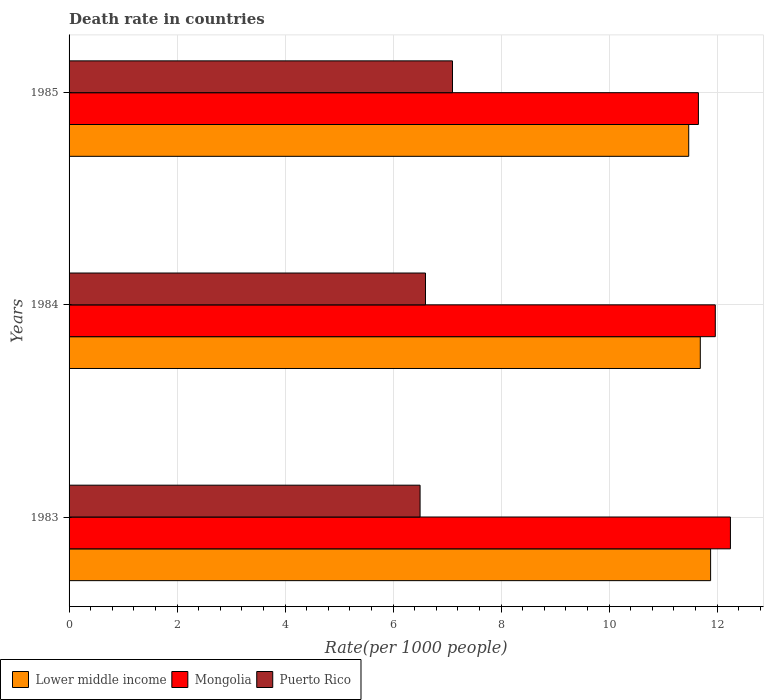Are the number of bars per tick equal to the number of legend labels?
Give a very brief answer. Yes. Are the number of bars on each tick of the Y-axis equal?
Keep it short and to the point. Yes. What is the label of the 2nd group of bars from the top?
Make the answer very short. 1984. In how many cases, is the number of bars for a given year not equal to the number of legend labels?
Give a very brief answer. 0. What is the death rate in Mongolia in 1983?
Ensure brevity in your answer.  12.25. Across all years, what is the maximum death rate in Lower middle income?
Provide a succinct answer. 11.88. Across all years, what is the minimum death rate in Mongolia?
Offer a very short reply. 11.65. In which year was the death rate in Mongolia minimum?
Provide a succinct answer. 1985. What is the total death rate in Lower middle income in the graph?
Provide a short and direct response. 35.04. What is the difference between the death rate in Puerto Rico in 1983 and that in 1984?
Your answer should be very brief. -0.1. What is the difference between the death rate in Lower middle income in 1983 and the death rate in Mongolia in 1984?
Ensure brevity in your answer.  -0.09. What is the average death rate in Puerto Rico per year?
Provide a succinct answer. 6.73. In the year 1983, what is the difference between the death rate in Mongolia and death rate in Puerto Rico?
Make the answer very short. 5.75. In how many years, is the death rate in Mongolia greater than 9.2 ?
Give a very brief answer. 3. What is the ratio of the death rate in Puerto Rico in 1983 to that in 1984?
Your answer should be compact. 0.98. Is the difference between the death rate in Mongolia in 1983 and 1984 greater than the difference between the death rate in Puerto Rico in 1983 and 1984?
Keep it short and to the point. Yes. What is the difference between the highest and the second highest death rate in Mongolia?
Your answer should be very brief. 0.28. What is the difference between the highest and the lowest death rate in Mongolia?
Provide a short and direct response. 0.59. Is the sum of the death rate in Mongolia in 1984 and 1985 greater than the maximum death rate in Puerto Rico across all years?
Ensure brevity in your answer.  Yes. What does the 3rd bar from the top in 1985 represents?
Provide a short and direct response. Lower middle income. What does the 2nd bar from the bottom in 1984 represents?
Provide a succinct answer. Mongolia. Is it the case that in every year, the sum of the death rate in Lower middle income and death rate in Puerto Rico is greater than the death rate in Mongolia?
Your response must be concise. Yes. How many years are there in the graph?
Give a very brief answer. 3. Are the values on the major ticks of X-axis written in scientific E-notation?
Your answer should be compact. No. How many legend labels are there?
Ensure brevity in your answer.  3. What is the title of the graph?
Provide a short and direct response. Death rate in countries. Does "Togo" appear as one of the legend labels in the graph?
Provide a succinct answer. No. What is the label or title of the X-axis?
Give a very brief answer. Rate(per 1000 people). What is the label or title of the Y-axis?
Offer a terse response. Years. What is the Rate(per 1000 people) in Lower middle income in 1983?
Your answer should be very brief. 11.88. What is the Rate(per 1000 people) of Mongolia in 1983?
Your answer should be compact. 12.25. What is the Rate(per 1000 people) in Puerto Rico in 1983?
Your answer should be compact. 6.5. What is the Rate(per 1000 people) of Lower middle income in 1984?
Provide a succinct answer. 11.69. What is the Rate(per 1000 people) of Mongolia in 1984?
Your answer should be very brief. 11.97. What is the Rate(per 1000 people) in Lower middle income in 1985?
Make the answer very short. 11.47. What is the Rate(per 1000 people) of Mongolia in 1985?
Provide a succinct answer. 11.65. Across all years, what is the maximum Rate(per 1000 people) of Lower middle income?
Give a very brief answer. 11.88. Across all years, what is the maximum Rate(per 1000 people) of Mongolia?
Keep it short and to the point. 12.25. Across all years, what is the maximum Rate(per 1000 people) in Puerto Rico?
Your answer should be very brief. 7.1. Across all years, what is the minimum Rate(per 1000 people) of Lower middle income?
Your answer should be very brief. 11.47. Across all years, what is the minimum Rate(per 1000 people) of Mongolia?
Provide a succinct answer. 11.65. Across all years, what is the minimum Rate(per 1000 people) of Puerto Rico?
Keep it short and to the point. 6.5. What is the total Rate(per 1000 people) of Lower middle income in the graph?
Your response must be concise. 35.04. What is the total Rate(per 1000 people) in Mongolia in the graph?
Provide a short and direct response. 35.87. What is the total Rate(per 1000 people) of Puerto Rico in the graph?
Your response must be concise. 20.2. What is the difference between the Rate(per 1000 people) of Lower middle income in 1983 and that in 1984?
Offer a very short reply. 0.19. What is the difference between the Rate(per 1000 people) of Mongolia in 1983 and that in 1984?
Give a very brief answer. 0.28. What is the difference between the Rate(per 1000 people) of Puerto Rico in 1983 and that in 1984?
Offer a very short reply. -0.1. What is the difference between the Rate(per 1000 people) of Lower middle income in 1983 and that in 1985?
Keep it short and to the point. 0.41. What is the difference between the Rate(per 1000 people) of Mongolia in 1983 and that in 1985?
Your response must be concise. 0.59. What is the difference between the Rate(per 1000 people) of Lower middle income in 1984 and that in 1985?
Give a very brief answer. 0.21. What is the difference between the Rate(per 1000 people) of Mongolia in 1984 and that in 1985?
Your answer should be very brief. 0.31. What is the difference between the Rate(per 1000 people) in Puerto Rico in 1984 and that in 1985?
Provide a succinct answer. -0.5. What is the difference between the Rate(per 1000 people) of Lower middle income in 1983 and the Rate(per 1000 people) of Mongolia in 1984?
Offer a terse response. -0.09. What is the difference between the Rate(per 1000 people) of Lower middle income in 1983 and the Rate(per 1000 people) of Puerto Rico in 1984?
Your answer should be compact. 5.28. What is the difference between the Rate(per 1000 people) in Mongolia in 1983 and the Rate(per 1000 people) in Puerto Rico in 1984?
Your response must be concise. 5.65. What is the difference between the Rate(per 1000 people) of Lower middle income in 1983 and the Rate(per 1000 people) of Mongolia in 1985?
Your answer should be very brief. 0.23. What is the difference between the Rate(per 1000 people) in Lower middle income in 1983 and the Rate(per 1000 people) in Puerto Rico in 1985?
Your answer should be compact. 4.78. What is the difference between the Rate(per 1000 people) in Mongolia in 1983 and the Rate(per 1000 people) in Puerto Rico in 1985?
Provide a succinct answer. 5.15. What is the difference between the Rate(per 1000 people) of Lower middle income in 1984 and the Rate(per 1000 people) of Mongolia in 1985?
Your response must be concise. 0.04. What is the difference between the Rate(per 1000 people) in Lower middle income in 1984 and the Rate(per 1000 people) in Puerto Rico in 1985?
Your answer should be very brief. 4.59. What is the difference between the Rate(per 1000 people) in Mongolia in 1984 and the Rate(per 1000 people) in Puerto Rico in 1985?
Give a very brief answer. 4.87. What is the average Rate(per 1000 people) in Lower middle income per year?
Provide a short and direct response. 11.68. What is the average Rate(per 1000 people) in Mongolia per year?
Provide a short and direct response. 11.96. What is the average Rate(per 1000 people) in Puerto Rico per year?
Your answer should be compact. 6.73. In the year 1983, what is the difference between the Rate(per 1000 people) in Lower middle income and Rate(per 1000 people) in Mongolia?
Ensure brevity in your answer.  -0.37. In the year 1983, what is the difference between the Rate(per 1000 people) of Lower middle income and Rate(per 1000 people) of Puerto Rico?
Make the answer very short. 5.38. In the year 1983, what is the difference between the Rate(per 1000 people) of Mongolia and Rate(per 1000 people) of Puerto Rico?
Make the answer very short. 5.75. In the year 1984, what is the difference between the Rate(per 1000 people) in Lower middle income and Rate(per 1000 people) in Mongolia?
Your answer should be compact. -0.28. In the year 1984, what is the difference between the Rate(per 1000 people) of Lower middle income and Rate(per 1000 people) of Puerto Rico?
Ensure brevity in your answer.  5.09. In the year 1984, what is the difference between the Rate(per 1000 people) of Mongolia and Rate(per 1000 people) of Puerto Rico?
Your answer should be very brief. 5.37. In the year 1985, what is the difference between the Rate(per 1000 people) in Lower middle income and Rate(per 1000 people) in Mongolia?
Your response must be concise. -0.18. In the year 1985, what is the difference between the Rate(per 1000 people) in Lower middle income and Rate(per 1000 people) in Puerto Rico?
Ensure brevity in your answer.  4.37. In the year 1985, what is the difference between the Rate(per 1000 people) of Mongolia and Rate(per 1000 people) of Puerto Rico?
Offer a terse response. 4.55. What is the ratio of the Rate(per 1000 people) in Lower middle income in 1983 to that in 1984?
Your answer should be very brief. 1.02. What is the ratio of the Rate(per 1000 people) in Mongolia in 1983 to that in 1984?
Offer a very short reply. 1.02. What is the ratio of the Rate(per 1000 people) in Puerto Rico in 1983 to that in 1984?
Make the answer very short. 0.98. What is the ratio of the Rate(per 1000 people) of Lower middle income in 1983 to that in 1985?
Give a very brief answer. 1.04. What is the ratio of the Rate(per 1000 people) in Mongolia in 1983 to that in 1985?
Your response must be concise. 1.05. What is the ratio of the Rate(per 1000 people) in Puerto Rico in 1983 to that in 1985?
Give a very brief answer. 0.92. What is the ratio of the Rate(per 1000 people) of Lower middle income in 1984 to that in 1985?
Provide a succinct answer. 1.02. What is the ratio of the Rate(per 1000 people) of Mongolia in 1984 to that in 1985?
Ensure brevity in your answer.  1.03. What is the ratio of the Rate(per 1000 people) in Puerto Rico in 1984 to that in 1985?
Your response must be concise. 0.93. What is the difference between the highest and the second highest Rate(per 1000 people) in Lower middle income?
Offer a very short reply. 0.19. What is the difference between the highest and the second highest Rate(per 1000 people) in Mongolia?
Offer a terse response. 0.28. What is the difference between the highest and the second highest Rate(per 1000 people) of Puerto Rico?
Your response must be concise. 0.5. What is the difference between the highest and the lowest Rate(per 1000 people) of Lower middle income?
Your answer should be very brief. 0.41. What is the difference between the highest and the lowest Rate(per 1000 people) in Mongolia?
Ensure brevity in your answer.  0.59. What is the difference between the highest and the lowest Rate(per 1000 people) of Puerto Rico?
Make the answer very short. 0.6. 